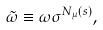Convert formula to latex. <formula><loc_0><loc_0><loc_500><loc_500>\tilde { \omega } \equiv \omega \sigma ^ { N _ { \mu } ( s ) } ,</formula> 